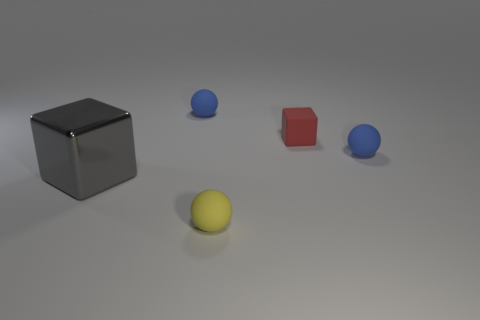Add 3 brown matte balls. How many objects exist? 8 Subtract all balls. How many objects are left? 2 Add 4 tiny blue spheres. How many tiny blue spheres exist? 6 Subtract 0 purple spheres. How many objects are left? 5 Subtract all metal objects. Subtract all metal objects. How many objects are left? 3 Add 5 tiny red cubes. How many tiny red cubes are left? 6 